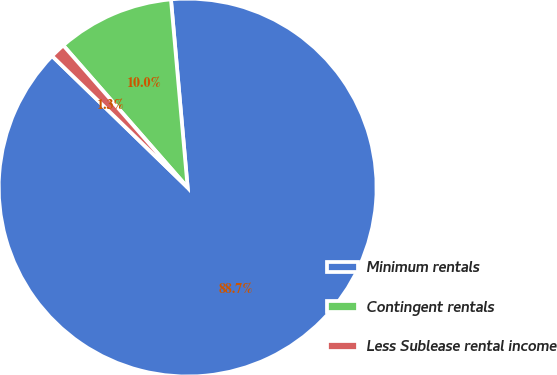<chart> <loc_0><loc_0><loc_500><loc_500><pie_chart><fcel>Minimum rentals<fcel>Contingent rentals<fcel>Less Sublease rental income<nl><fcel>88.67%<fcel>10.03%<fcel>1.3%<nl></chart> 